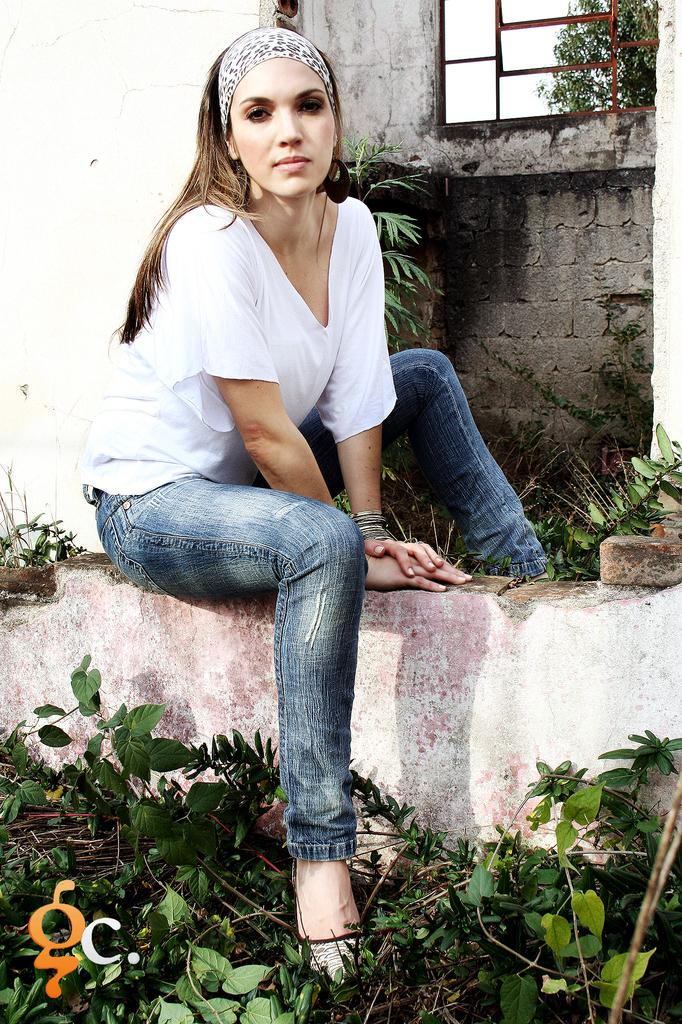What is the woman in the image doing? The woman is sitting on the wall in the image. What can be seen in the image besides the woman? There are plants and a window visible in the image. Where is the window located in the image? The window is visible in the background of the image. Is there any text or marking on the image? Yes, there is a watermark at the bottom left side of the image. What type of joke is being told by the plants in the image? There are no jokes being told by the plants in the image, as plants do not have the ability to communicate or tell jokes. 